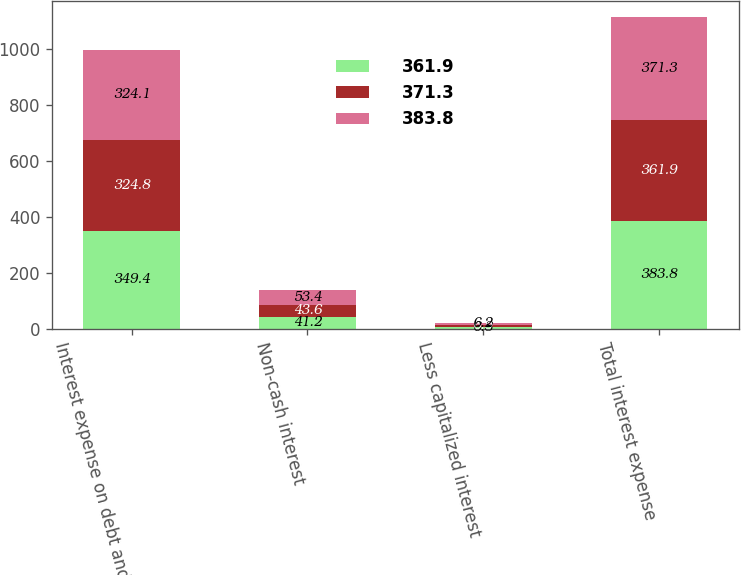Convert chart. <chart><loc_0><loc_0><loc_500><loc_500><stacked_bar_chart><ecel><fcel>Interest expense on debt and<fcel>Non-cash interest<fcel>Less capitalized interest<fcel>Total interest expense<nl><fcel>361.9<fcel>349.4<fcel>41.2<fcel>6.8<fcel>383.8<nl><fcel>371.3<fcel>324.8<fcel>43.6<fcel>6.5<fcel>361.9<nl><fcel>383.8<fcel>324.1<fcel>53.4<fcel>6.2<fcel>371.3<nl></chart> 